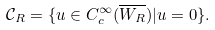Convert formula to latex. <formula><loc_0><loc_0><loc_500><loc_500>\mathcal { C } _ { R } = \{ u \in C _ { c } ^ { \infty } ( \overline { W _ { R } } ) | u = 0 \} .</formula> 